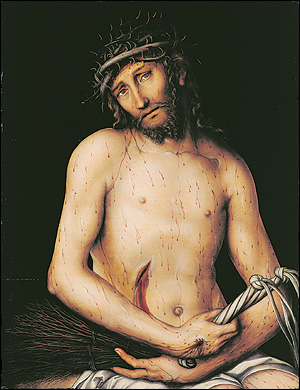What are the key elements in this picture?
 The image is a realistic painting that primarily uses dark colors, with the exception of the man's pale skin and the white cloth draped over his lap. The man in the painting is depicted with a crown of thorns on his head, sitting with his arms crossed over his lap. His body and face show signs of physical and emotional pain. The painting is likely a religious piece, depicting the crucifixion of Jesus Christ. The art style is realistic, and the genre is likely religious art. The painting's use of color and detail contribute to its somber and solemn mood. The artist has skillfully used light and shadow to highlight the man's suffering and the significance of the scene. 